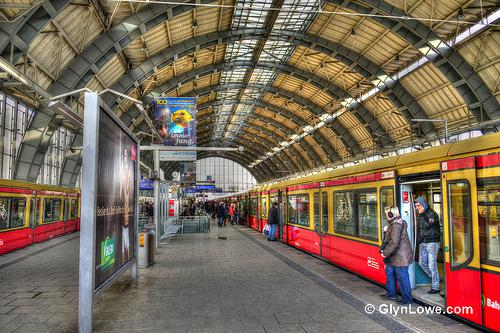Question: what are the people wearing?
Choices:
A. Jackets.
B. Shoes.
C. Skis.
D. Gloves.
Answer with the letter. Answer: A Question: where is this taking place?
Choices:
A. Inside a railway station.
B. On a boat.
C. In a train.
D. On a plane.
Answer with the letter. Answer: A Question: why do the people wear jackets?
Choices:
A. To block the wind.
B. It's cold outside.
C. To stay warm.
D. To keep dry.
Answer with the letter. Answer: B Question: how do the people travel?
Choices:
A. On horseback.
B. On bicycles.
C. In a plane.
D. By train.
Answer with the letter. Answer: D Question: who is getting off the train?
Choices:
A. Two people.
B. The old woman.
C. The young man.
D. The conductor.
Answer with the letter. Answer: A Question: what colors are the trains?
Choices:
A. Red and yellow.
B. Teal.
C. Purple.
D. Neon.
Answer with the letter. Answer: A Question: what is on the platform?
Choices:
A. Large signs.
B. People.
C. A yellow line.
D. Concrete.
Answer with the letter. Answer: A 